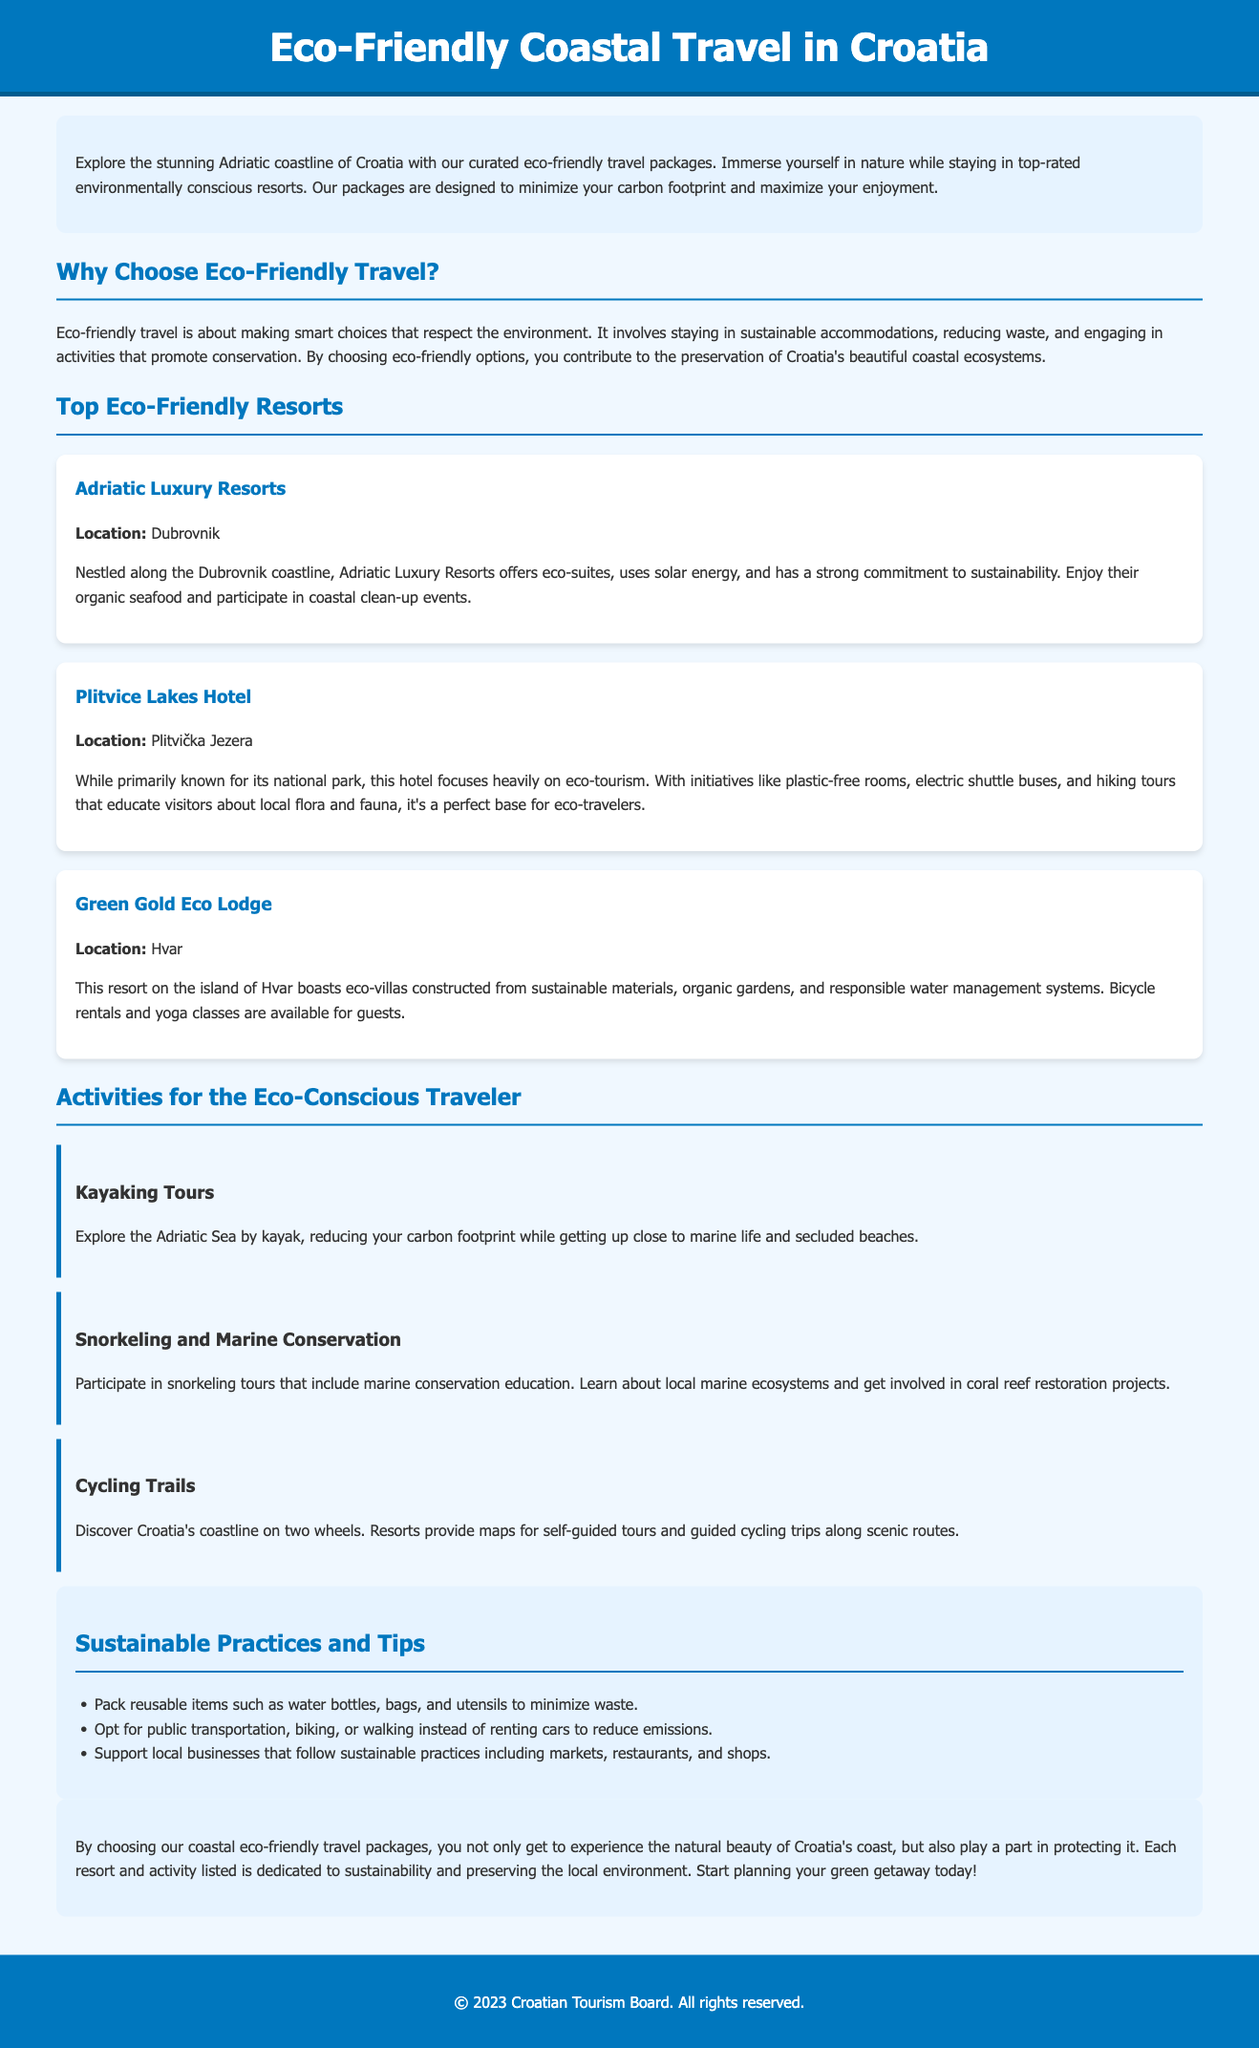What is the title of the document? The title is listed in the header of the document.
Answer: Eco-Friendly Coastal Travel in Croatia Which resort is located in Dubrovnik? This information is provided within the section listing the top eco-friendly resorts.
Answer: Adriatic Luxury Resorts What sustainable feature does Plitvice Lakes Hotel emphasize? The document mentions several features of the hotel.
Answer: Plastic-free rooms Name one activity for eco-conscious travelers. Activities are listed in a dedicated section in the document.
Answer: Kayaking Tours What is one tip for sustainable practices mentioned in the document? The tips section includes several recommendations.
Answer: Pack reusable items What commitment does Adriatic Luxury Resorts have? The document specifies the resort's dedication to sustainable practices.
Answer: Strong commitment to sustainability How many eco-friendly resorts are featured in the document? This refers to the count of resorts listed under the top eco-friendly resorts section.
Answer: Three What initiative does Green Gold Eco Lodge offer? The document highlights various offerings of the resort.
Answer: Bicycle rentals 